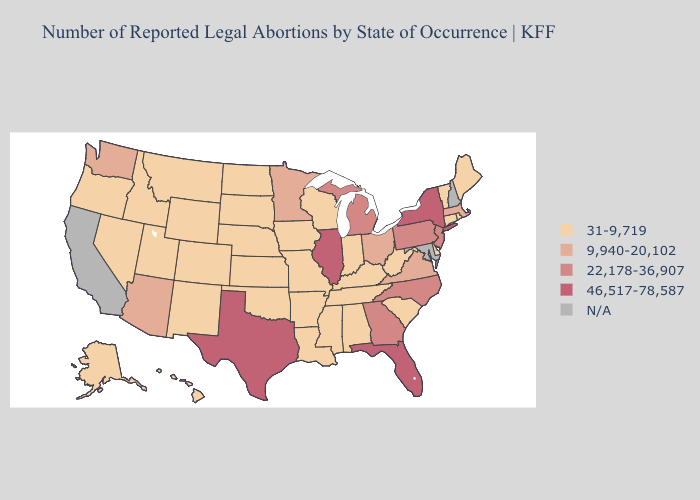Does the map have missing data?
Keep it brief. Yes. What is the highest value in states that border Wisconsin?
Quick response, please. 46,517-78,587. What is the lowest value in the Northeast?
Answer briefly. 31-9,719. What is the lowest value in states that border Georgia?
Give a very brief answer. 31-9,719. Which states have the lowest value in the USA?
Quick response, please. Alabama, Alaska, Arkansas, Colorado, Connecticut, Delaware, Hawaii, Idaho, Indiana, Iowa, Kansas, Kentucky, Louisiana, Maine, Mississippi, Missouri, Montana, Nebraska, Nevada, New Mexico, North Dakota, Oklahoma, Oregon, Rhode Island, South Carolina, South Dakota, Tennessee, Utah, Vermont, West Virginia, Wisconsin, Wyoming. Is the legend a continuous bar?
Concise answer only. No. Does New York have the highest value in the USA?
Be succinct. Yes. What is the lowest value in the West?
Concise answer only. 31-9,719. Name the states that have a value in the range 9,940-20,102?
Give a very brief answer. Arizona, Massachusetts, Minnesota, Ohio, Virginia, Washington. Name the states that have a value in the range 9,940-20,102?
Keep it brief. Arizona, Massachusetts, Minnesota, Ohio, Virginia, Washington. What is the highest value in the South ?
Quick response, please. 46,517-78,587. Name the states that have a value in the range 31-9,719?
Give a very brief answer. Alabama, Alaska, Arkansas, Colorado, Connecticut, Delaware, Hawaii, Idaho, Indiana, Iowa, Kansas, Kentucky, Louisiana, Maine, Mississippi, Missouri, Montana, Nebraska, Nevada, New Mexico, North Dakota, Oklahoma, Oregon, Rhode Island, South Carolina, South Dakota, Tennessee, Utah, Vermont, West Virginia, Wisconsin, Wyoming. Among the states that border Florida , does Alabama have the lowest value?
Answer briefly. Yes. What is the value of Utah?
Concise answer only. 31-9,719. Name the states that have a value in the range 31-9,719?
Answer briefly. Alabama, Alaska, Arkansas, Colorado, Connecticut, Delaware, Hawaii, Idaho, Indiana, Iowa, Kansas, Kentucky, Louisiana, Maine, Mississippi, Missouri, Montana, Nebraska, Nevada, New Mexico, North Dakota, Oklahoma, Oregon, Rhode Island, South Carolina, South Dakota, Tennessee, Utah, Vermont, West Virginia, Wisconsin, Wyoming. 